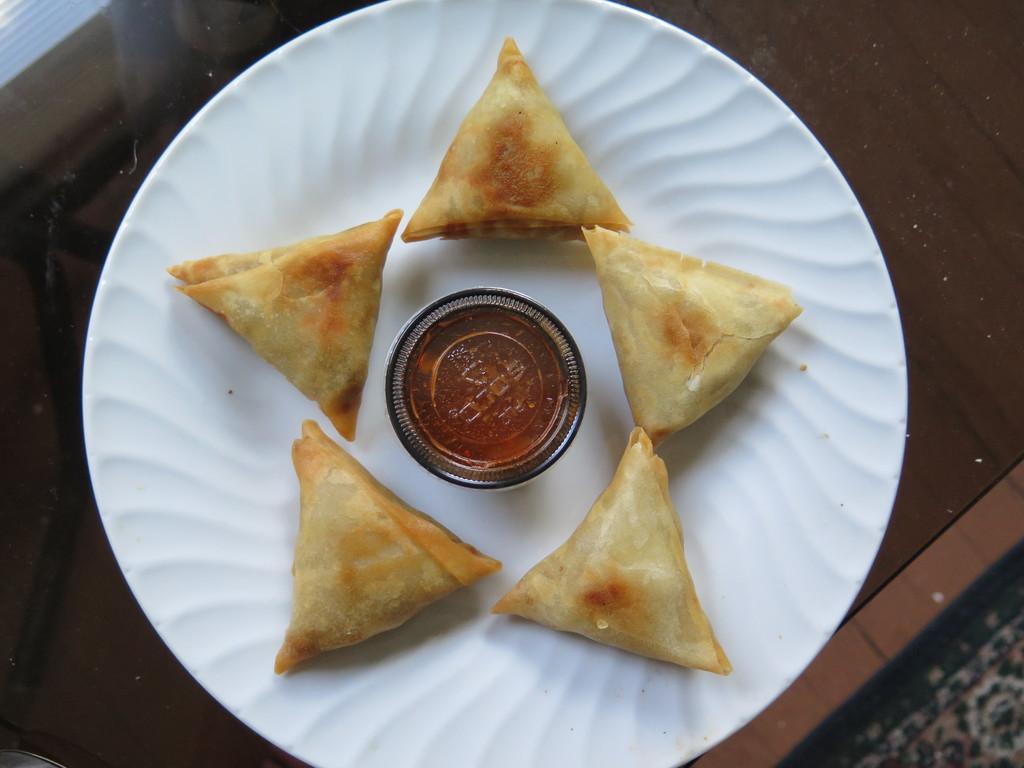How would you summarize this image in a sentence or two? In this picture there is a food on the plate. There is a plate on the table. In the bottom right there is a mat. 